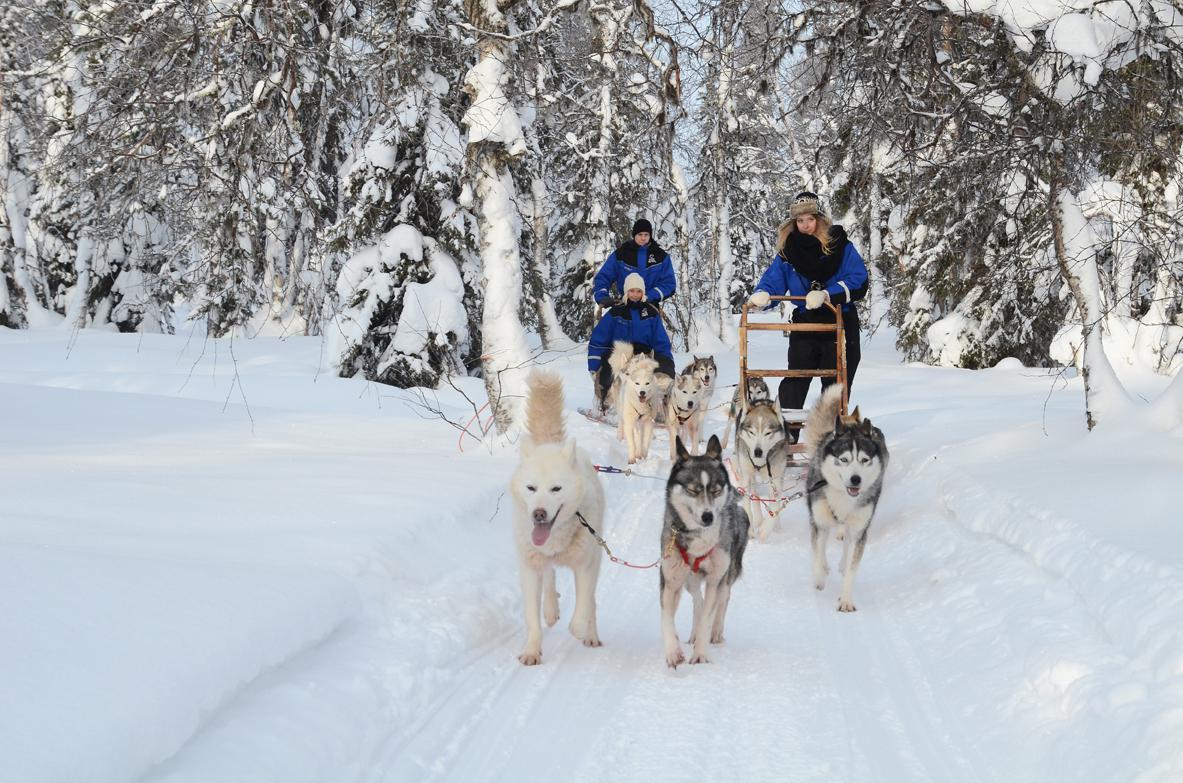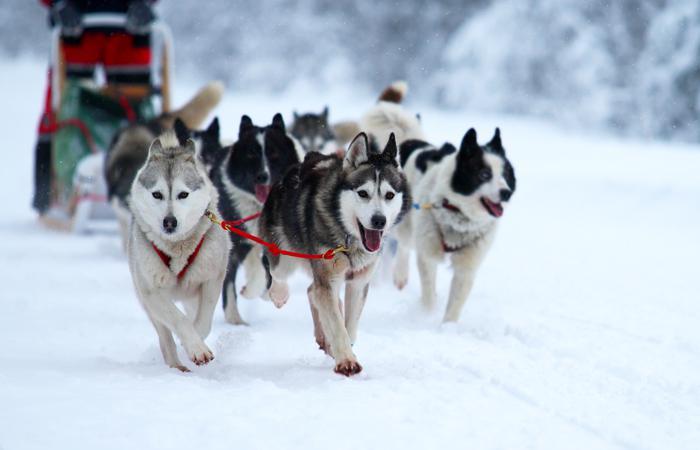The first image is the image on the left, the second image is the image on the right. Examine the images to the left and right. Is the description "In both images, the sled dogs are heading in nearly the same direction." accurate? Answer yes or no. Yes. The first image is the image on the left, the second image is the image on the right. For the images displayed, is the sentence "In one image, dog sleds are traveling close to and between large snow covered trees." factually correct? Answer yes or no. Yes. 